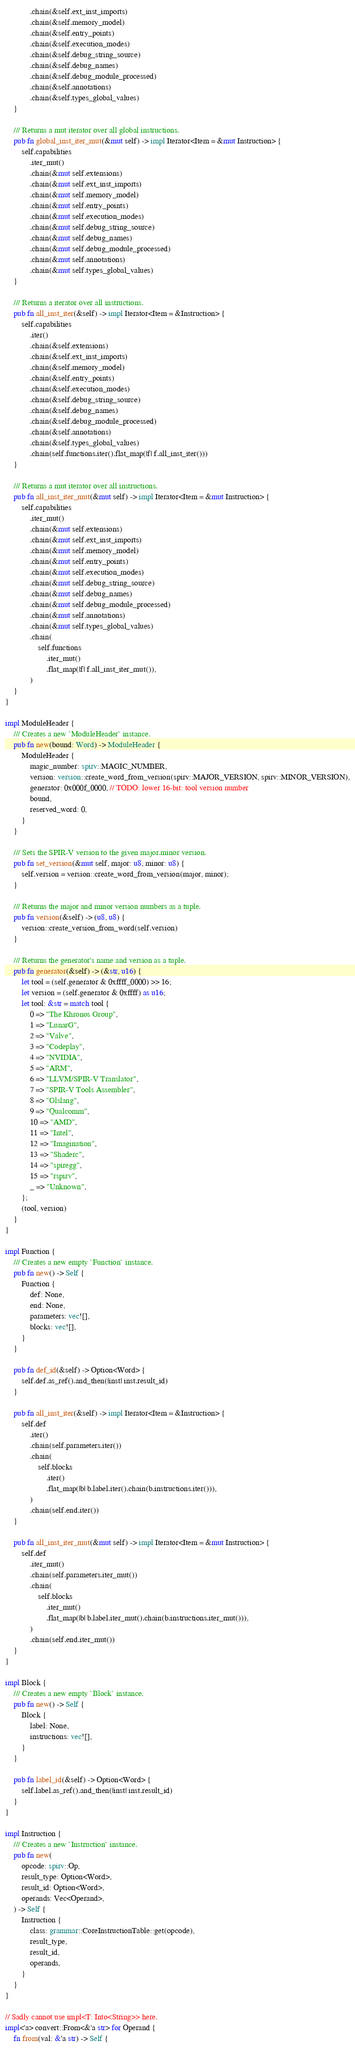<code> <loc_0><loc_0><loc_500><loc_500><_Rust_>            .chain(&self.ext_inst_imports)
            .chain(&self.memory_model)
            .chain(&self.entry_points)
            .chain(&self.execution_modes)
            .chain(&self.debug_string_source)
            .chain(&self.debug_names)
            .chain(&self.debug_module_processed)
            .chain(&self.annotations)
            .chain(&self.types_global_values)
    }

    /// Returns a mut iterator over all global instructions.
    pub fn global_inst_iter_mut(&mut self) -> impl Iterator<Item = &mut Instruction> {
        self.capabilities
            .iter_mut()
            .chain(&mut self.extensions)
            .chain(&mut self.ext_inst_imports)
            .chain(&mut self.memory_model)
            .chain(&mut self.entry_points)
            .chain(&mut self.execution_modes)
            .chain(&mut self.debug_string_source)
            .chain(&mut self.debug_names)
            .chain(&mut self.debug_module_processed)
            .chain(&mut self.annotations)
            .chain(&mut self.types_global_values)
    }

    /// Returns a iterator over all instructions.
    pub fn all_inst_iter(&self) -> impl Iterator<Item = &Instruction> {
        self.capabilities
            .iter()
            .chain(&self.extensions)
            .chain(&self.ext_inst_imports)
            .chain(&self.memory_model)
            .chain(&self.entry_points)
            .chain(&self.execution_modes)
            .chain(&self.debug_string_source)
            .chain(&self.debug_names)
            .chain(&self.debug_module_processed)
            .chain(&self.annotations)
            .chain(&self.types_global_values)
            .chain(self.functions.iter().flat_map(|f| f.all_inst_iter()))
    }

    /// Returns a mut iterator over all instructions.
    pub fn all_inst_iter_mut(&mut self) -> impl Iterator<Item = &mut Instruction> {
        self.capabilities
            .iter_mut()
            .chain(&mut self.extensions)
            .chain(&mut self.ext_inst_imports)
            .chain(&mut self.memory_model)
            .chain(&mut self.entry_points)
            .chain(&mut self.execution_modes)
            .chain(&mut self.debug_string_source)
            .chain(&mut self.debug_names)
            .chain(&mut self.debug_module_processed)
            .chain(&mut self.annotations)
            .chain(&mut self.types_global_values)
            .chain(
                self.functions
                    .iter_mut()
                    .flat_map(|f| f.all_inst_iter_mut()),
            )
    }
}

impl ModuleHeader {
    /// Creates a new `ModuleHeader` instance.
    pub fn new(bound: Word) -> ModuleHeader {
        ModuleHeader {
            magic_number: spirv::MAGIC_NUMBER,
            version: version::create_word_from_version(spirv::MAJOR_VERSION, spirv::MINOR_VERSION),
            generator: 0x000f_0000, // TODO: lower 16-bit: tool version number
            bound,
            reserved_word: 0,
        }
    }

    /// Sets the SPIR-V version to the given major.minor version.
    pub fn set_version(&mut self, major: u8, minor: u8) {
        self.version = version::create_word_from_version(major, minor);
    }

    /// Returns the major and minor version numbers as a tuple.
    pub fn version(&self) -> (u8, u8) {
        version::create_version_from_word(self.version)
    }

    /// Returns the generator's name and version as a tuple.
    pub fn generator(&self) -> (&str, u16) {
        let tool = (self.generator & 0xffff_0000) >> 16;
        let version = (self.generator & 0xffff) as u16;
        let tool: &str = match tool {
            0 => "The Khronos Group",
            1 => "LunarG",
            2 => "Valve",
            3 => "Codeplay",
            4 => "NVIDIA",
            5 => "ARM",
            6 => "LLVM/SPIR-V Translator",
            7 => "SPIR-V Tools Assembler",
            8 => "Glslang",
            9 => "Qualcomm",
            10 => "AMD",
            11 => "Intel",
            12 => "Imagination",
            13 => "Shaderc",
            14 => "spiregg",
            15 => "rspirv",
            _ => "Unknown",
        };
        (tool, version)
    }
}

impl Function {
    /// Creates a new empty `Function` instance.
    pub fn new() -> Self {
        Function {
            def: None,
            end: None,
            parameters: vec![],
            blocks: vec![],
        }
    }

    pub fn def_id(&self) -> Option<Word> {
        self.def.as_ref().and_then(|inst| inst.result_id)
    }

    pub fn all_inst_iter(&self) -> impl Iterator<Item = &Instruction> {
        self.def
            .iter()
            .chain(self.parameters.iter())
            .chain(
                self.blocks
                    .iter()
                    .flat_map(|b| b.label.iter().chain(b.instructions.iter())),
            )
            .chain(self.end.iter())
    }

    pub fn all_inst_iter_mut(&mut self) -> impl Iterator<Item = &mut Instruction> {
        self.def
            .iter_mut()
            .chain(self.parameters.iter_mut())
            .chain(
                self.blocks
                    .iter_mut()
                    .flat_map(|b| b.label.iter_mut().chain(b.instructions.iter_mut())),
            )
            .chain(self.end.iter_mut())
    }
}

impl Block {
    /// Creates a new empty `Block` instance.
    pub fn new() -> Self {
        Block {
            label: None,
            instructions: vec![],
        }
    }

    pub fn label_id(&self) -> Option<Word> {
        self.label.as_ref().and_then(|inst| inst.result_id)
    }
}

impl Instruction {
    /// Creates a new `Instruction` instance.
    pub fn new(
        opcode: spirv::Op,
        result_type: Option<Word>,
        result_id: Option<Word>,
        operands: Vec<Operand>,
    ) -> Self {
        Instruction {
            class: grammar::CoreInstructionTable::get(opcode),
            result_type,
            result_id,
            operands,
        }
    }
}

// Sadly cannot use impl<T: Into<String>> here.
impl<'a> convert::From<&'a str> for Operand {
    fn from(val: &'a str) -> Self {</code> 